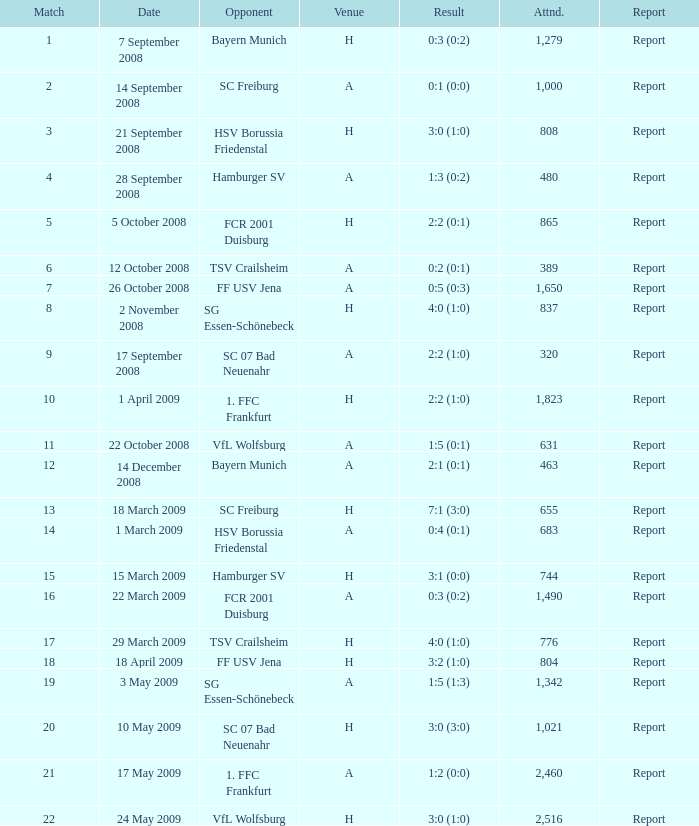In which game did fcr 2001 duisburg play as the opposing team? 21.0. 